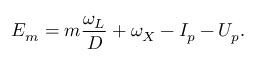Convert formula to latex. <formula><loc_0><loc_0><loc_500><loc_500>E _ { m } = m \frac { \omega _ { L } } { D } + \omega _ { X } - I _ { p } - U _ { p } .</formula> 